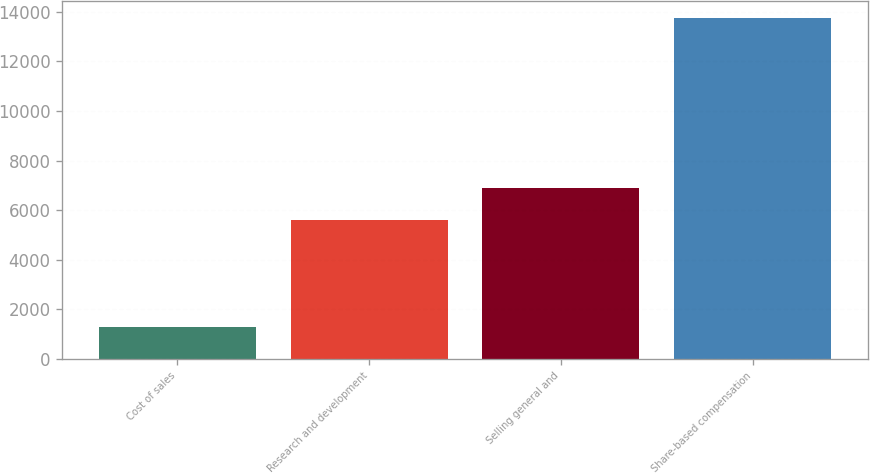<chart> <loc_0><loc_0><loc_500><loc_500><bar_chart><fcel>Cost of sales<fcel>Research and development<fcel>Selling general and<fcel>Share-based compensation<nl><fcel>1274<fcel>5590<fcel>6873<fcel>13737<nl></chart> 